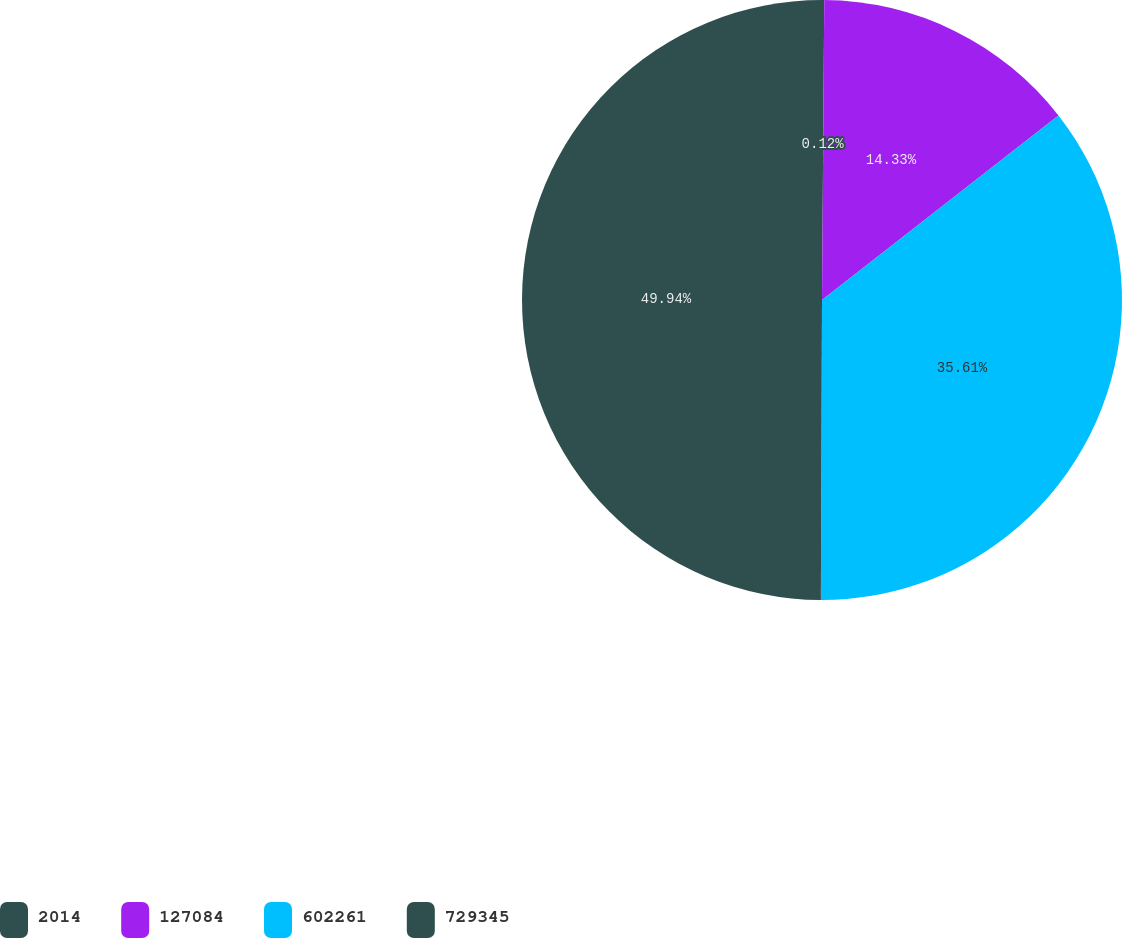Convert chart. <chart><loc_0><loc_0><loc_500><loc_500><pie_chart><fcel>2014<fcel>127084<fcel>602261<fcel>729345<nl><fcel>0.12%<fcel>14.33%<fcel>35.61%<fcel>49.94%<nl></chart> 